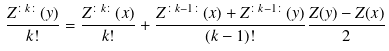<formula> <loc_0><loc_0><loc_500><loc_500>\frac { Z ^ { \colon k \colon } ( y ) } { k ! } = \frac { Z ^ { \colon k \colon } ( x ) } { k ! } + \frac { Z ^ { \colon k - 1 \colon } ( x ) + Z ^ { \colon k - 1 \colon } ( y ) } { ( k - 1 ) ! } \frac { Z ( y ) - Z ( x ) } { 2 }</formula> 